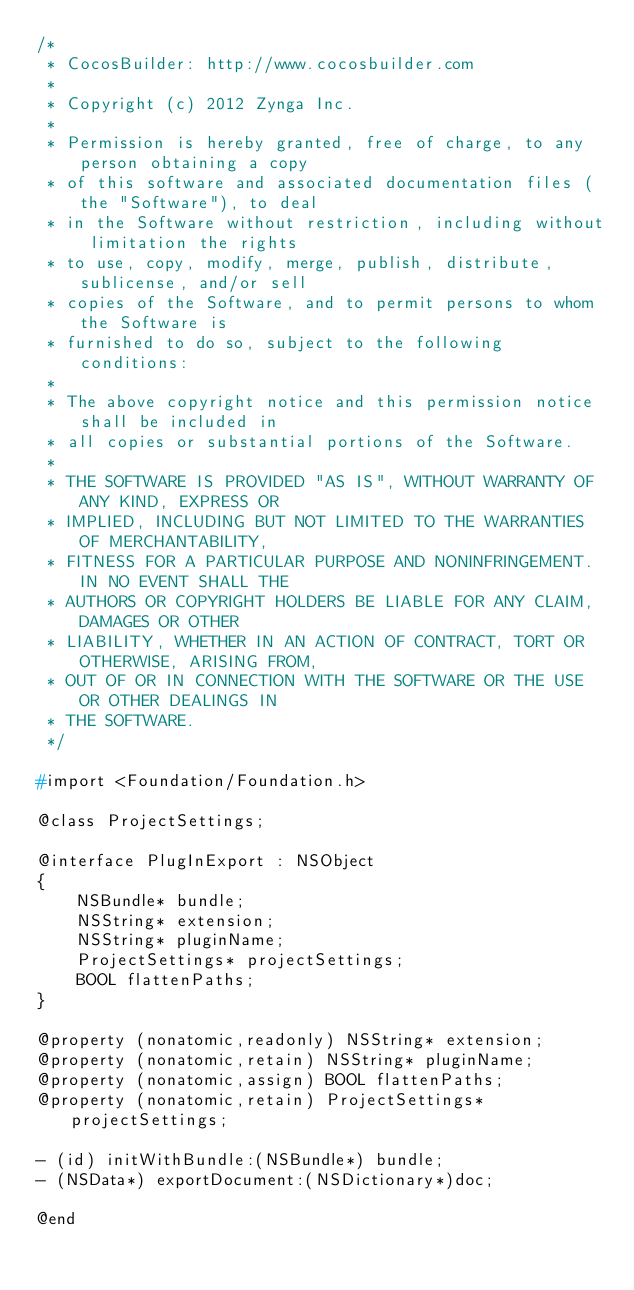Convert code to text. <code><loc_0><loc_0><loc_500><loc_500><_C_>/*
 * CocosBuilder: http://www.cocosbuilder.com
 *
 * Copyright (c) 2012 Zynga Inc.
 *
 * Permission is hereby granted, free of charge, to any person obtaining a copy
 * of this software and associated documentation files (the "Software"), to deal
 * in the Software without restriction, including without limitation the rights
 * to use, copy, modify, merge, publish, distribute, sublicense, and/or sell
 * copies of the Software, and to permit persons to whom the Software is
 * furnished to do so, subject to the following conditions:
 *
 * The above copyright notice and this permission notice shall be included in
 * all copies or substantial portions of the Software.
 *
 * THE SOFTWARE IS PROVIDED "AS IS", WITHOUT WARRANTY OF ANY KIND, EXPRESS OR
 * IMPLIED, INCLUDING BUT NOT LIMITED TO THE WARRANTIES OF MERCHANTABILITY,
 * FITNESS FOR A PARTICULAR PURPOSE AND NONINFRINGEMENT. IN NO EVENT SHALL THE
 * AUTHORS OR COPYRIGHT HOLDERS BE LIABLE FOR ANY CLAIM, DAMAGES OR OTHER
 * LIABILITY, WHETHER IN AN ACTION OF CONTRACT, TORT OR OTHERWISE, ARISING FROM,
 * OUT OF OR IN CONNECTION WITH THE SOFTWARE OR THE USE OR OTHER DEALINGS IN
 * THE SOFTWARE.
 */

#import <Foundation/Foundation.h>

@class ProjectSettings;

@interface PlugInExport : NSObject
{
    NSBundle* bundle;
    NSString* extension;
    NSString* pluginName;
    ProjectSettings* projectSettings;
    BOOL flattenPaths;
}

@property (nonatomic,readonly) NSString* extension;
@property (nonatomic,retain) NSString* pluginName;
@property (nonatomic,assign) BOOL flattenPaths;
@property (nonatomic,retain) ProjectSettings* projectSettings;

- (id) initWithBundle:(NSBundle*) bundle;
- (NSData*) exportDocument:(NSDictionary*)doc;

@end</code> 